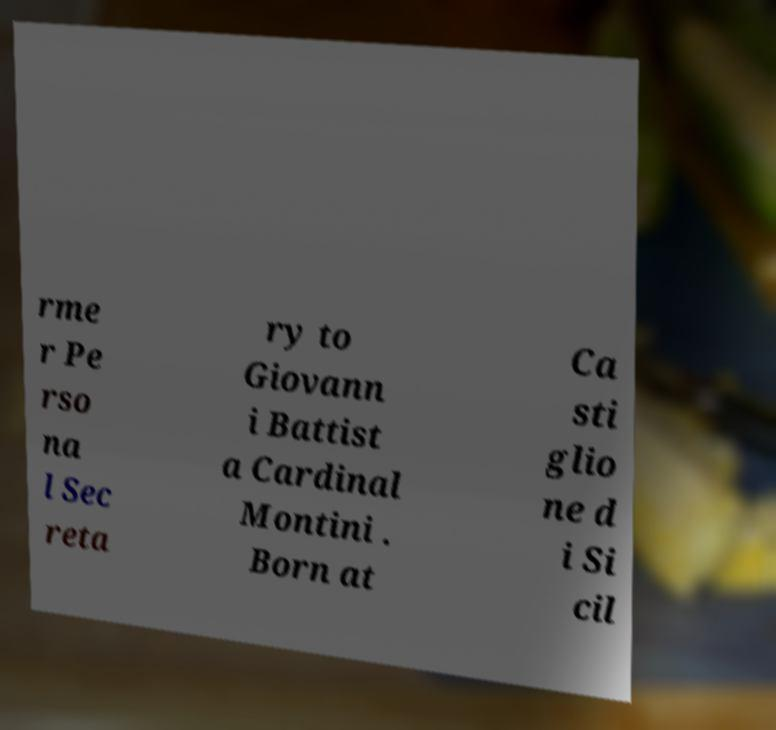I need the written content from this picture converted into text. Can you do that? rme r Pe rso na l Sec reta ry to Giovann i Battist a Cardinal Montini . Born at Ca sti glio ne d i Si cil 